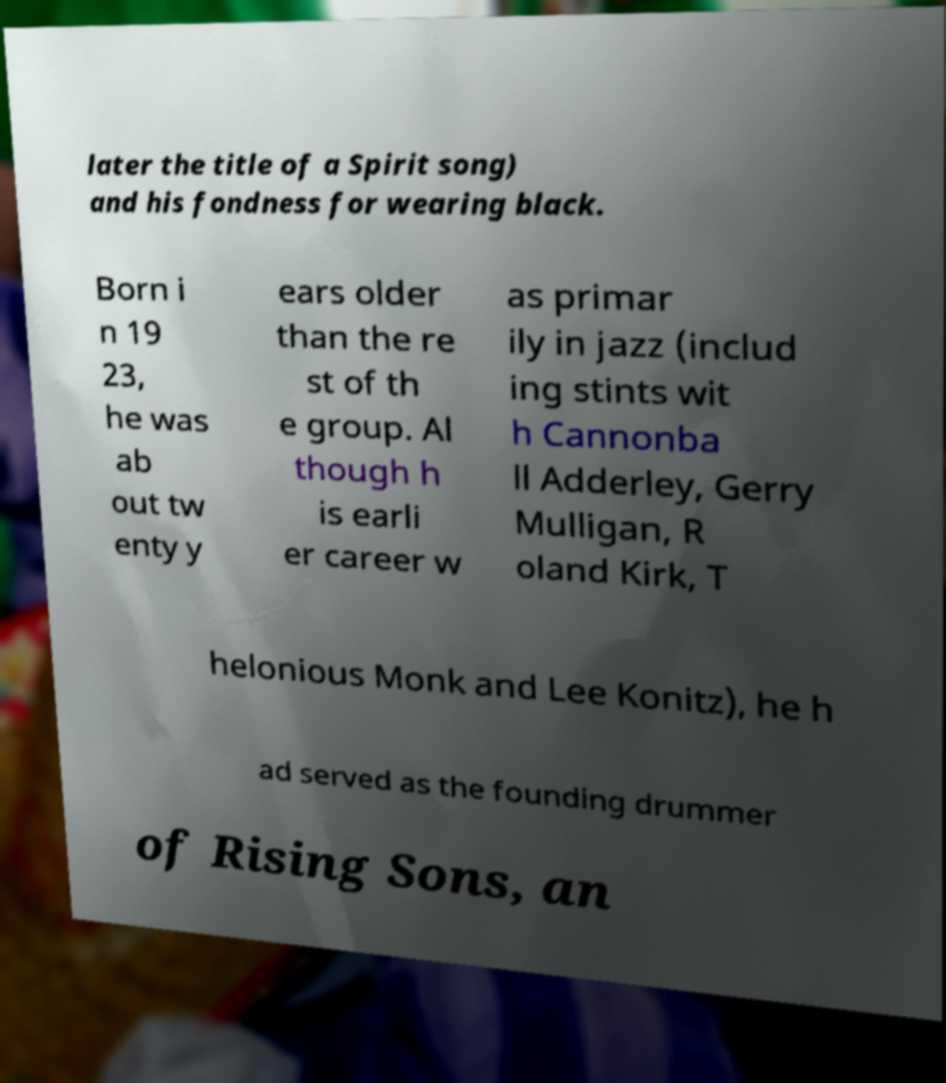Can you accurately transcribe the text from the provided image for me? later the title of a Spirit song) and his fondness for wearing black. Born i n 19 23, he was ab out tw enty y ears older than the re st of th e group. Al though h is earli er career w as primar ily in jazz (includ ing stints wit h Cannonba ll Adderley, Gerry Mulligan, R oland Kirk, T helonious Monk and Lee Konitz), he h ad served as the founding drummer of Rising Sons, an 